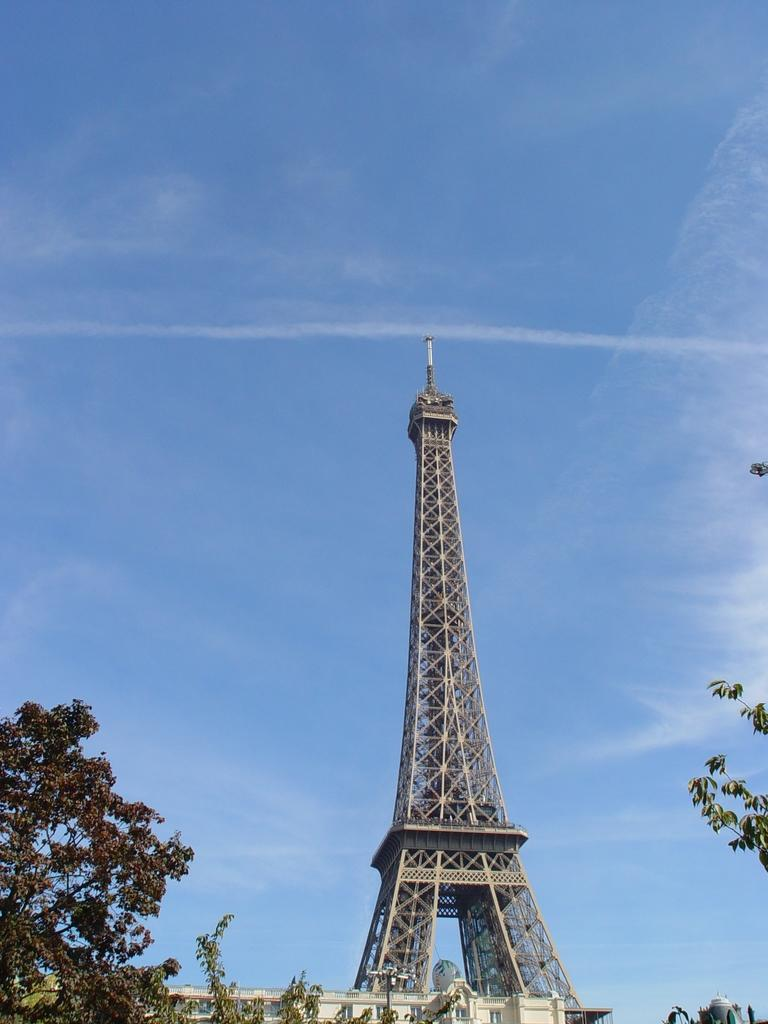What famous landmark can be seen in the image? The Eiffel tower is present in the image. What type of vegetation is visible at the foreground of the image? There are trees at the foreground of the image. What is the condition of the sky in the image? The sky is clear at the top of the image. What type of feast is being prepared in the image? There is no indication of a feast being prepared in the image; it primarily features the Eiffel tower and surrounding vegetation. 